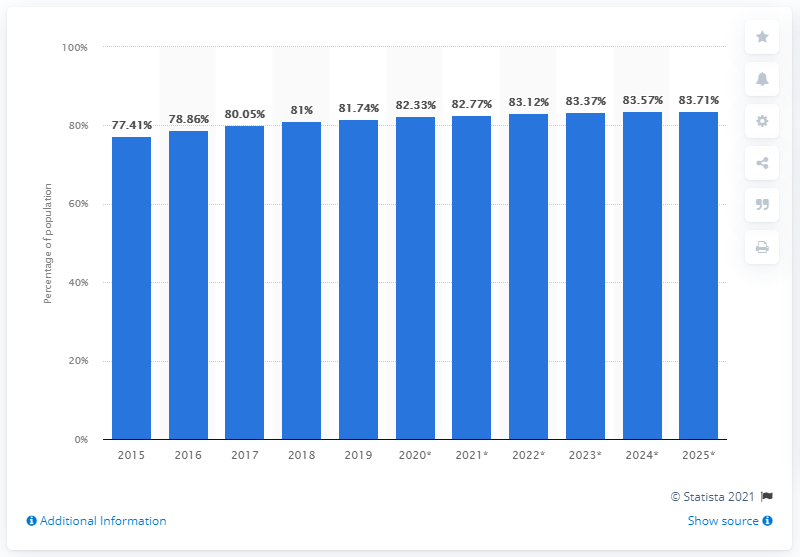Indicate a few pertinent items in this graphic. In 2019, approximately 82.77% of Singapore's population accessed the internet from their mobile phones. 